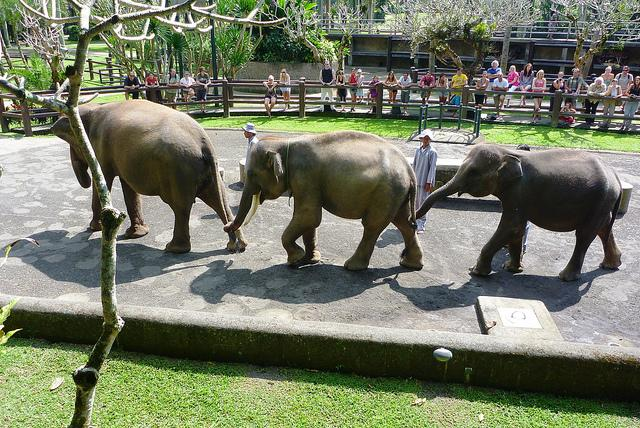What direction are the elephants marching? left 